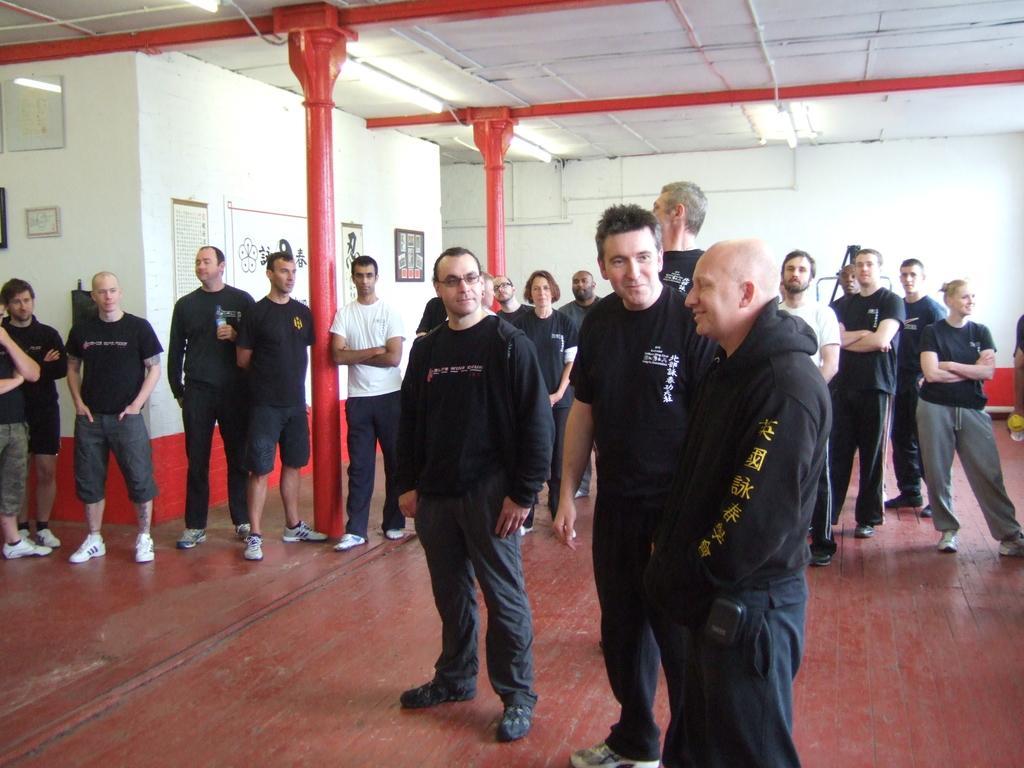Please provide a concise description of this image. In the hall there are many people standing. On the wall there are paintings, hangings. Most of them are wearing black dress. There are red pillars in the room. 